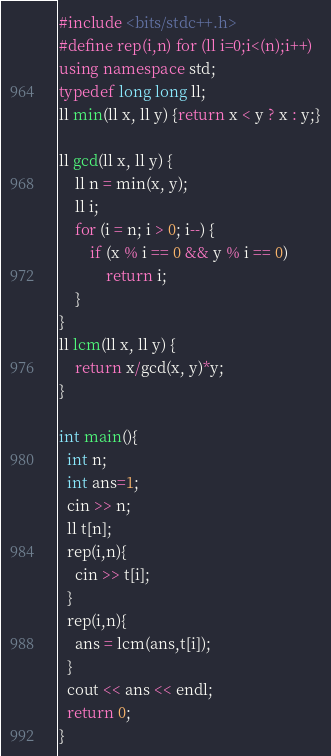Convert code to text. <code><loc_0><loc_0><loc_500><loc_500><_C++_>#include <bits/stdc++.h>
#define rep(i,n) for (ll i=0;i<(n);i++)
using namespace std;
typedef long long ll;
ll min(ll x, ll y) {return x < y ? x : y;}

ll gcd(ll x, ll y) {
    ll n = min(x, y);
    ll i;
    for (i = n; i > 0; i--) {
        if (x % i == 0 && y % i == 0)
            return i;
    }
}
ll lcm(ll x, ll y) {
    return x/gcd(x, y)*y;
}

int main(){
  int n;
  int ans=1;
  cin >> n;
  ll t[n];
  rep(i,n){
    cin >> t[i];
  }
  rep(i,n){
    ans = lcm(ans,t[i]);
  }
  cout << ans << endl;
  return 0;
}</code> 